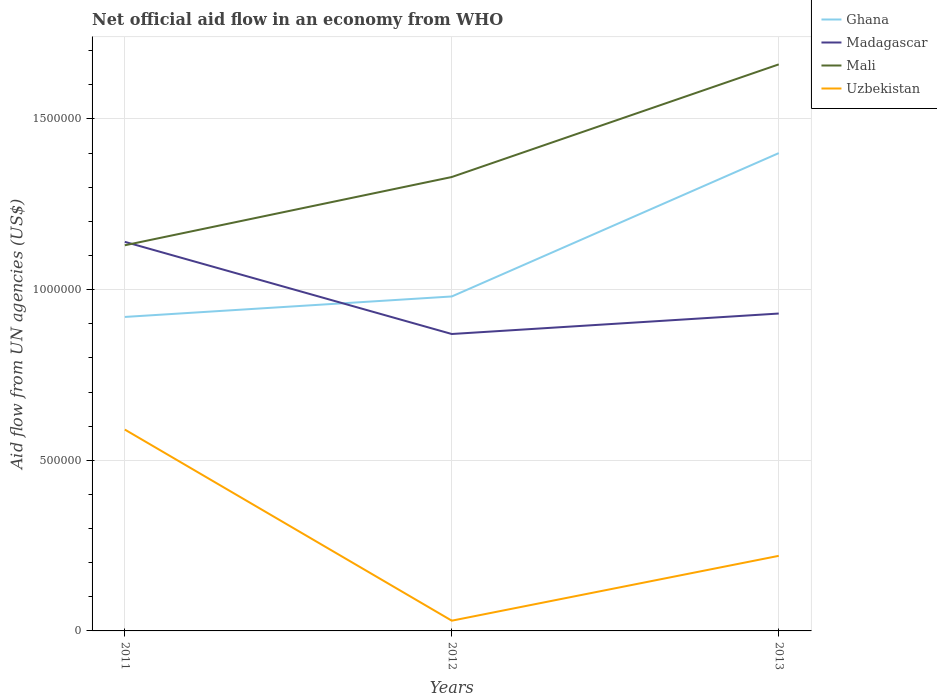In which year was the net official aid flow in Madagascar maximum?
Give a very brief answer. 2012. What is the total net official aid flow in Mali in the graph?
Your response must be concise. -5.30e+05. How many years are there in the graph?
Provide a succinct answer. 3. What is the difference between two consecutive major ticks on the Y-axis?
Your answer should be very brief. 5.00e+05. Are the values on the major ticks of Y-axis written in scientific E-notation?
Your answer should be compact. No. Does the graph contain grids?
Your answer should be very brief. Yes. Where does the legend appear in the graph?
Provide a succinct answer. Top right. What is the title of the graph?
Offer a very short reply. Net official aid flow in an economy from WHO. Does "Senegal" appear as one of the legend labels in the graph?
Ensure brevity in your answer.  No. What is the label or title of the Y-axis?
Ensure brevity in your answer.  Aid flow from UN agencies (US$). What is the Aid flow from UN agencies (US$) of Ghana in 2011?
Provide a succinct answer. 9.20e+05. What is the Aid flow from UN agencies (US$) in Madagascar in 2011?
Offer a terse response. 1.14e+06. What is the Aid flow from UN agencies (US$) in Mali in 2011?
Your response must be concise. 1.13e+06. What is the Aid flow from UN agencies (US$) in Uzbekistan in 2011?
Keep it short and to the point. 5.90e+05. What is the Aid flow from UN agencies (US$) of Ghana in 2012?
Your answer should be compact. 9.80e+05. What is the Aid flow from UN agencies (US$) of Madagascar in 2012?
Your answer should be compact. 8.70e+05. What is the Aid flow from UN agencies (US$) of Mali in 2012?
Offer a terse response. 1.33e+06. What is the Aid flow from UN agencies (US$) of Uzbekistan in 2012?
Provide a short and direct response. 3.00e+04. What is the Aid flow from UN agencies (US$) of Ghana in 2013?
Offer a terse response. 1.40e+06. What is the Aid flow from UN agencies (US$) of Madagascar in 2013?
Your answer should be very brief. 9.30e+05. What is the Aid flow from UN agencies (US$) in Mali in 2013?
Your response must be concise. 1.66e+06. Across all years, what is the maximum Aid flow from UN agencies (US$) of Ghana?
Offer a terse response. 1.40e+06. Across all years, what is the maximum Aid flow from UN agencies (US$) in Madagascar?
Ensure brevity in your answer.  1.14e+06. Across all years, what is the maximum Aid flow from UN agencies (US$) in Mali?
Keep it short and to the point. 1.66e+06. Across all years, what is the maximum Aid flow from UN agencies (US$) in Uzbekistan?
Make the answer very short. 5.90e+05. Across all years, what is the minimum Aid flow from UN agencies (US$) in Ghana?
Ensure brevity in your answer.  9.20e+05. Across all years, what is the minimum Aid flow from UN agencies (US$) in Madagascar?
Make the answer very short. 8.70e+05. Across all years, what is the minimum Aid flow from UN agencies (US$) of Mali?
Provide a succinct answer. 1.13e+06. Across all years, what is the minimum Aid flow from UN agencies (US$) of Uzbekistan?
Your answer should be compact. 3.00e+04. What is the total Aid flow from UN agencies (US$) of Ghana in the graph?
Ensure brevity in your answer.  3.30e+06. What is the total Aid flow from UN agencies (US$) in Madagascar in the graph?
Keep it short and to the point. 2.94e+06. What is the total Aid flow from UN agencies (US$) of Mali in the graph?
Keep it short and to the point. 4.12e+06. What is the total Aid flow from UN agencies (US$) of Uzbekistan in the graph?
Your answer should be very brief. 8.40e+05. What is the difference between the Aid flow from UN agencies (US$) in Mali in 2011 and that in 2012?
Your answer should be compact. -2.00e+05. What is the difference between the Aid flow from UN agencies (US$) in Uzbekistan in 2011 and that in 2012?
Keep it short and to the point. 5.60e+05. What is the difference between the Aid flow from UN agencies (US$) of Ghana in 2011 and that in 2013?
Keep it short and to the point. -4.80e+05. What is the difference between the Aid flow from UN agencies (US$) in Mali in 2011 and that in 2013?
Your response must be concise. -5.30e+05. What is the difference between the Aid flow from UN agencies (US$) of Uzbekistan in 2011 and that in 2013?
Your answer should be compact. 3.70e+05. What is the difference between the Aid flow from UN agencies (US$) in Ghana in 2012 and that in 2013?
Offer a terse response. -4.20e+05. What is the difference between the Aid flow from UN agencies (US$) of Madagascar in 2012 and that in 2013?
Your answer should be very brief. -6.00e+04. What is the difference between the Aid flow from UN agencies (US$) in Mali in 2012 and that in 2013?
Give a very brief answer. -3.30e+05. What is the difference between the Aid flow from UN agencies (US$) in Uzbekistan in 2012 and that in 2013?
Your answer should be very brief. -1.90e+05. What is the difference between the Aid flow from UN agencies (US$) of Ghana in 2011 and the Aid flow from UN agencies (US$) of Madagascar in 2012?
Keep it short and to the point. 5.00e+04. What is the difference between the Aid flow from UN agencies (US$) in Ghana in 2011 and the Aid flow from UN agencies (US$) in Mali in 2012?
Make the answer very short. -4.10e+05. What is the difference between the Aid flow from UN agencies (US$) of Ghana in 2011 and the Aid flow from UN agencies (US$) of Uzbekistan in 2012?
Provide a short and direct response. 8.90e+05. What is the difference between the Aid flow from UN agencies (US$) in Madagascar in 2011 and the Aid flow from UN agencies (US$) in Mali in 2012?
Your answer should be very brief. -1.90e+05. What is the difference between the Aid flow from UN agencies (US$) in Madagascar in 2011 and the Aid flow from UN agencies (US$) in Uzbekistan in 2012?
Make the answer very short. 1.11e+06. What is the difference between the Aid flow from UN agencies (US$) of Mali in 2011 and the Aid flow from UN agencies (US$) of Uzbekistan in 2012?
Your answer should be compact. 1.10e+06. What is the difference between the Aid flow from UN agencies (US$) of Ghana in 2011 and the Aid flow from UN agencies (US$) of Madagascar in 2013?
Your answer should be very brief. -10000. What is the difference between the Aid flow from UN agencies (US$) of Ghana in 2011 and the Aid flow from UN agencies (US$) of Mali in 2013?
Offer a very short reply. -7.40e+05. What is the difference between the Aid flow from UN agencies (US$) in Ghana in 2011 and the Aid flow from UN agencies (US$) in Uzbekistan in 2013?
Provide a succinct answer. 7.00e+05. What is the difference between the Aid flow from UN agencies (US$) of Madagascar in 2011 and the Aid flow from UN agencies (US$) of Mali in 2013?
Ensure brevity in your answer.  -5.20e+05. What is the difference between the Aid flow from UN agencies (US$) of Madagascar in 2011 and the Aid flow from UN agencies (US$) of Uzbekistan in 2013?
Ensure brevity in your answer.  9.20e+05. What is the difference between the Aid flow from UN agencies (US$) of Mali in 2011 and the Aid flow from UN agencies (US$) of Uzbekistan in 2013?
Your response must be concise. 9.10e+05. What is the difference between the Aid flow from UN agencies (US$) in Ghana in 2012 and the Aid flow from UN agencies (US$) in Mali in 2013?
Keep it short and to the point. -6.80e+05. What is the difference between the Aid flow from UN agencies (US$) of Ghana in 2012 and the Aid flow from UN agencies (US$) of Uzbekistan in 2013?
Your answer should be very brief. 7.60e+05. What is the difference between the Aid flow from UN agencies (US$) of Madagascar in 2012 and the Aid flow from UN agencies (US$) of Mali in 2013?
Provide a short and direct response. -7.90e+05. What is the difference between the Aid flow from UN agencies (US$) of Madagascar in 2012 and the Aid flow from UN agencies (US$) of Uzbekistan in 2013?
Offer a terse response. 6.50e+05. What is the difference between the Aid flow from UN agencies (US$) in Mali in 2012 and the Aid flow from UN agencies (US$) in Uzbekistan in 2013?
Keep it short and to the point. 1.11e+06. What is the average Aid flow from UN agencies (US$) of Ghana per year?
Your answer should be compact. 1.10e+06. What is the average Aid flow from UN agencies (US$) of Madagascar per year?
Provide a short and direct response. 9.80e+05. What is the average Aid flow from UN agencies (US$) of Mali per year?
Offer a terse response. 1.37e+06. In the year 2011, what is the difference between the Aid flow from UN agencies (US$) of Ghana and Aid flow from UN agencies (US$) of Mali?
Your response must be concise. -2.10e+05. In the year 2011, what is the difference between the Aid flow from UN agencies (US$) in Ghana and Aid flow from UN agencies (US$) in Uzbekistan?
Your answer should be very brief. 3.30e+05. In the year 2011, what is the difference between the Aid flow from UN agencies (US$) in Madagascar and Aid flow from UN agencies (US$) in Mali?
Your response must be concise. 10000. In the year 2011, what is the difference between the Aid flow from UN agencies (US$) in Mali and Aid flow from UN agencies (US$) in Uzbekistan?
Give a very brief answer. 5.40e+05. In the year 2012, what is the difference between the Aid flow from UN agencies (US$) in Ghana and Aid flow from UN agencies (US$) in Mali?
Ensure brevity in your answer.  -3.50e+05. In the year 2012, what is the difference between the Aid flow from UN agencies (US$) of Ghana and Aid flow from UN agencies (US$) of Uzbekistan?
Make the answer very short. 9.50e+05. In the year 2012, what is the difference between the Aid flow from UN agencies (US$) in Madagascar and Aid flow from UN agencies (US$) in Mali?
Give a very brief answer. -4.60e+05. In the year 2012, what is the difference between the Aid flow from UN agencies (US$) in Madagascar and Aid flow from UN agencies (US$) in Uzbekistan?
Provide a succinct answer. 8.40e+05. In the year 2012, what is the difference between the Aid flow from UN agencies (US$) of Mali and Aid flow from UN agencies (US$) of Uzbekistan?
Offer a terse response. 1.30e+06. In the year 2013, what is the difference between the Aid flow from UN agencies (US$) in Ghana and Aid flow from UN agencies (US$) in Madagascar?
Your response must be concise. 4.70e+05. In the year 2013, what is the difference between the Aid flow from UN agencies (US$) of Ghana and Aid flow from UN agencies (US$) of Mali?
Your answer should be compact. -2.60e+05. In the year 2013, what is the difference between the Aid flow from UN agencies (US$) in Ghana and Aid flow from UN agencies (US$) in Uzbekistan?
Provide a short and direct response. 1.18e+06. In the year 2013, what is the difference between the Aid flow from UN agencies (US$) in Madagascar and Aid flow from UN agencies (US$) in Mali?
Keep it short and to the point. -7.30e+05. In the year 2013, what is the difference between the Aid flow from UN agencies (US$) of Madagascar and Aid flow from UN agencies (US$) of Uzbekistan?
Your answer should be compact. 7.10e+05. In the year 2013, what is the difference between the Aid flow from UN agencies (US$) of Mali and Aid flow from UN agencies (US$) of Uzbekistan?
Offer a very short reply. 1.44e+06. What is the ratio of the Aid flow from UN agencies (US$) in Ghana in 2011 to that in 2012?
Keep it short and to the point. 0.94. What is the ratio of the Aid flow from UN agencies (US$) of Madagascar in 2011 to that in 2012?
Offer a very short reply. 1.31. What is the ratio of the Aid flow from UN agencies (US$) of Mali in 2011 to that in 2012?
Your answer should be compact. 0.85. What is the ratio of the Aid flow from UN agencies (US$) in Uzbekistan in 2011 to that in 2012?
Your answer should be very brief. 19.67. What is the ratio of the Aid flow from UN agencies (US$) in Ghana in 2011 to that in 2013?
Keep it short and to the point. 0.66. What is the ratio of the Aid flow from UN agencies (US$) in Madagascar in 2011 to that in 2013?
Your answer should be very brief. 1.23. What is the ratio of the Aid flow from UN agencies (US$) of Mali in 2011 to that in 2013?
Ensure brevity in your answer.  0.68. What is the ratio of the Aid flow from UN agencies (US$) in Uzbekistan in 2011 to that in 2013?
Ensure brevity in your answer.  2.68. What is the ratio of the Aid flow from UN agencies (US$) of Madagascar in 2012 to that in 2013?
Offer a very short reply. 0.94. What is the ratio of the Aid flow from UN agencies (US$) in Mali in 2012 to that in 2013?
Your answer should be compact. 0.8. What is the ratio of the Aid flow from UN agencies (US$) in Uzbekistan in 2012 to that in 2013?
Your answer should be compact. 0.14. What is the difference between the highest and the second highest Aid flow from UN agencies (US$) of Ghana?
Provide a short and direct response. 4.20e+05. What is the difference between the highest and the second highest Aid flow from UN agencies (US$) of Madagascar?
Offer a terse response. 2.10e+05. What is the difference between the highest and the second highest Aid flow from UN agencies (US$) of Uzbekistan?
Provide a succinct answer. 3.70e+05. What is the difference between the highest and the lowest Aid flow from UN agencies (US$) of Ghana?
Give a very brief answer. 4.80e+05. What is the difference between the highest and the lowest Aid flow from UN agencies (US$) in Mali?
Your answer should be very brief. 5.30e+05. What is the difference between the highest and the lowest Aid flow from UN agencies (US$) of Uzbekistan?
Ensure brevity in your answer.  5.60e+05. 